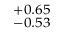<formula> <loc_0><loc_0><loc_500><loc_500>^ { + 0 . 6 5 } _ { - 0 . 5 3 }</formula> 